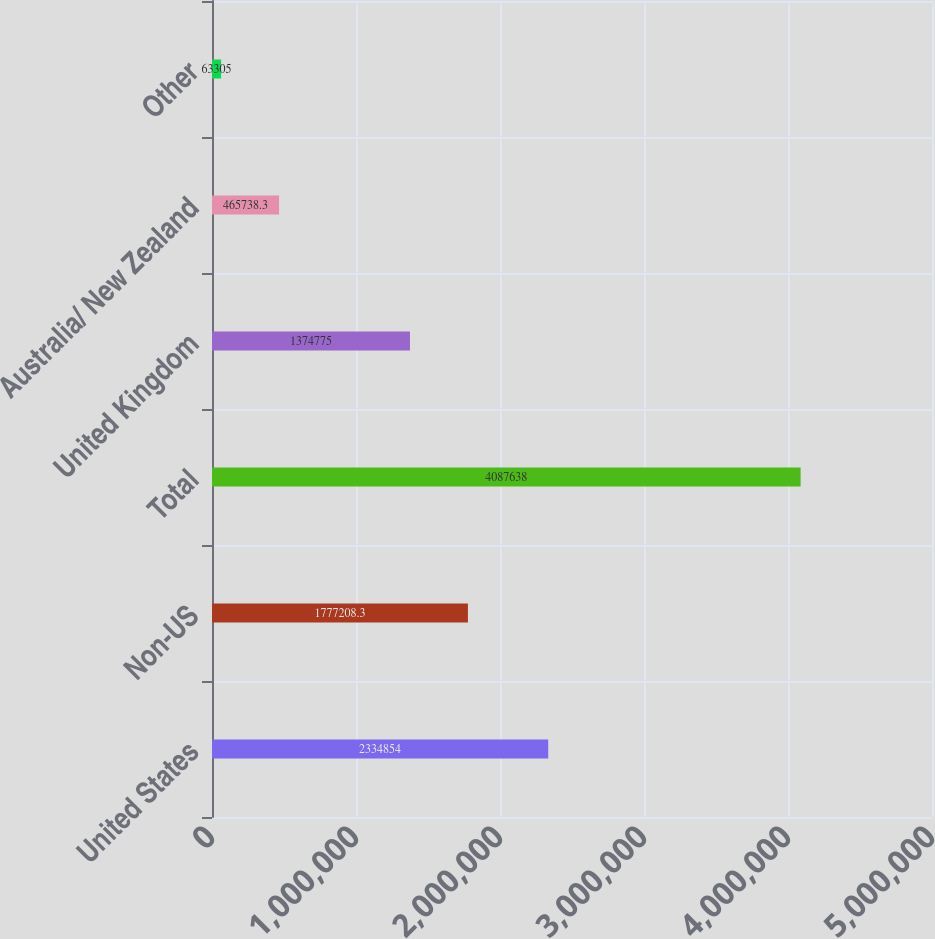Convert chart to OTSL. <chart><loc_0><loc_0><loc_500><loc_500><bar_chart><fcel>United States<fcel>Non-US<fcel>Total<fcel>United Kingdom<fcel>Australia/ New Zealand<fcel>Other<nl><fcel>2.33485e+06<fcel>1.77721e+06<fcel>4.08764e+06<fcel>1.37478e+06<fcel>465738<fcel>63305<nl></chart> 